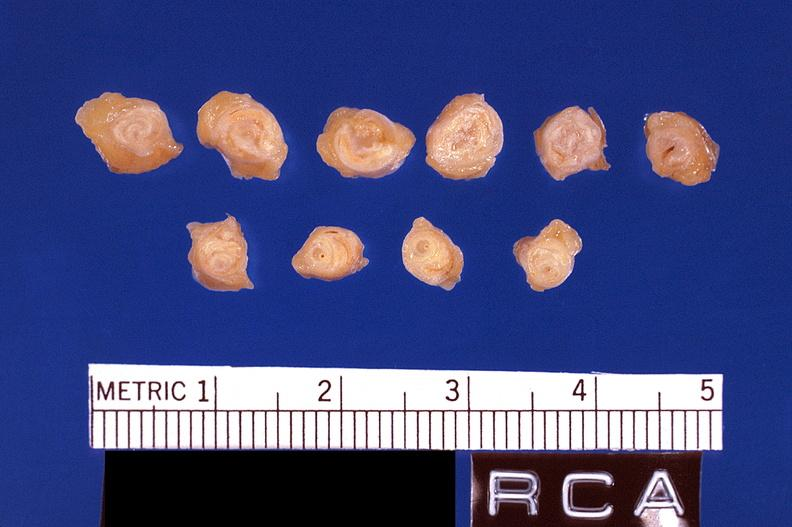s lesion of myocytolysis present?
Answer the question using a single word or phrase. No 